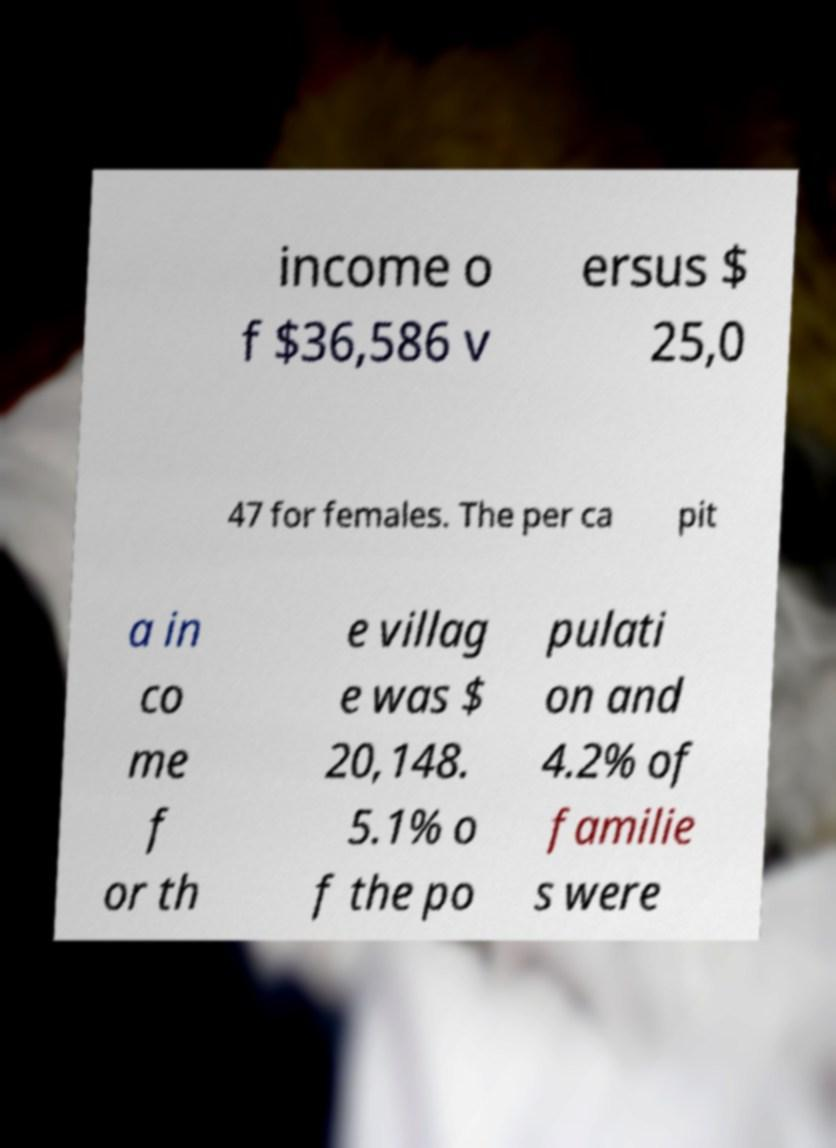Could you assist in decoding the text presented in this image and type it out clearly? income o f $36,586 v ersus $ 25,0 47 for females. The per ca pit a in co me f or th e villag e was $ 20,148. 5.1% o f the po pulati on and 4.2% of familie s were 